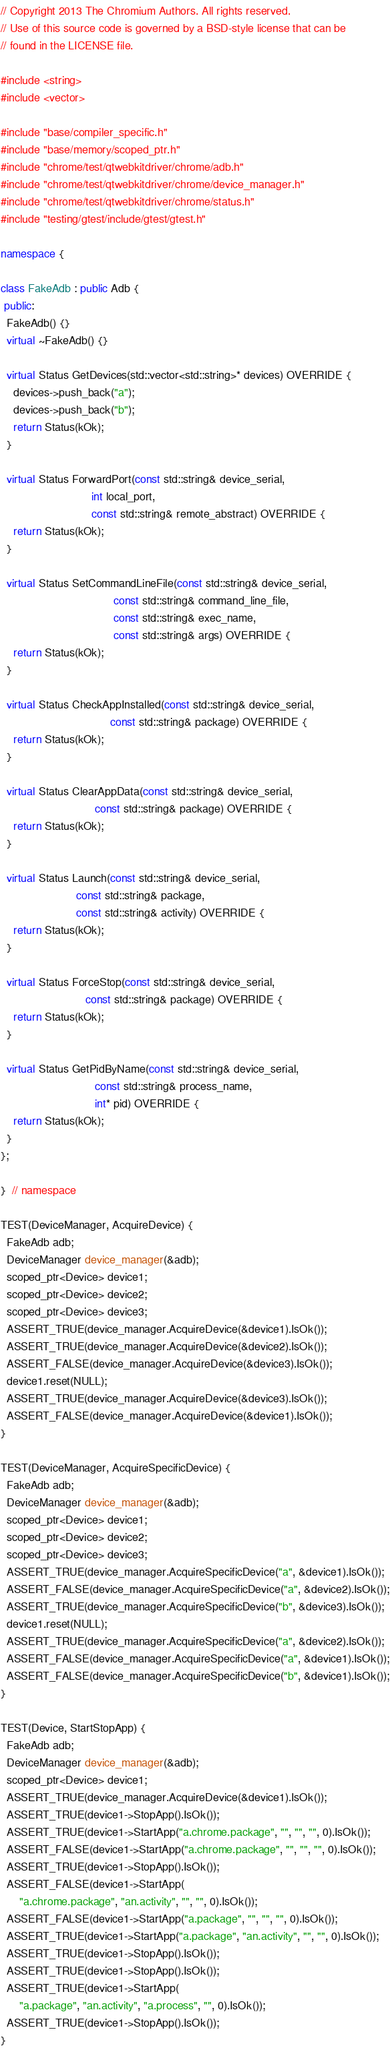<code> <loc_0><loc_0><loc_500><loc_500><_C++_>// Copyright 2013 The Chromium Authors. All rights reserved.
// Use of this source code is governed by a BSD-style license that can be
// found in the LICENSE file.

#include <string>
#include <vector>

#include "base/compiler_specific.h"
#include "base/memory/scoped_ptr.h"
#include "chrome/test/qtwebkitdriver/chrome/adb.h"
#include "chrome/test/qtwebkitdriver/chrome/device_manager.h"
#include "chrome/test/qtwebkitdriver/chrome/status.h"
#include "testing/gtest/include/gtest/gtest.h"

namespace {

class FakeAdb : public Adb {
 public:
  FakeAdb() {}
  virtual ~FakeAdb() {}

  virtual Status GetDevices(std::vector<std::string>* devices) OVERRIDE {
    devices->push_back("a");
    devices->push_back("b");
    return Status(kOk);
  }

  virtual Status ForwardPort(const std::string& device_serial,
                             int local_port,
                             const std::string& remote_abstract) OVERRIDE {
    return Status(kOk);
  }

  virtual Status SetCommandLineFile(const std::string& device_serial,
                                    const std::string& command_line_file,
                                    const std::string& exec_name,
                                    const std::string& args) OVERRIDE {
    return Status(kOk);
  }

  virtual Status CheckAppInstalled(const std::string& device_serial,
                                   const std::string& package) OVERRIDE {
    return Status(kOk);
  }

  virtual Status ClearAppData(const std::string& device_serial,
                              const std::string& package) OVERRIDE {
    return Status(kOk);
  }

  virtual Status Launch(const std::string& device_serial,
                        const std::string& package,
                        const std::string& activity) OVERRIDE {
    return Status(kOk);
  }

  virtual Status ForceStop(const std::string& device_serial,
                           const std::string& package) OVERRIDE {
    return Status(kOk);
  }

  virtual Status GetPidByName(const std::string& device_serial,
                              const std::string& process_name,
                              int* pid) OVERRIDE {
    return Status(kOk);
  }
};

}  // namespace

TEST(DeviceManager, AcquireDevice) {
  FakeAdb adb;
  DeviceManager device_manager(&adb);
  scoped_ptr<Device> device1;
  scoped_ptr<Device> device2;
  scoped_ptr<Device> device3;
  ASSERT_TRUE(device_manager.AcquireDevice(&device1).IsOk());
  ASSERT_TRUE(device_manager.AcquireDevice(&device2).IsOk());
  ASSERT_FALSE(device_manager.AcquireDevice(&device3).IsOk());
  device1.reset(NULL);
  ASSERT_TRUE(device_manager.AcquireDevice(&device3).IsOk());
  ASSERT_FALSE(device_manager.AcquireDevice(&device1).IsOk());
}

TEST(DeviceManager, AcquireSpecificDevice) {
  FakeAdb adb;
  DeviceManager device_manager(&adb);
  scoped_ptr<Device> device1;
  scoped_ptr<Device> device2;
  scoped_ptr<Device> device3;
  ASSERT_TRUE(device_manager.AcquireSpecificDevice("a", &device1).IsOk());
  ASSERT_FALSE(device_manager.AcquireSpecificDevice("a", &device2).IsOk());
  ASSERT_TRUE(device_manager.AcquireSpecificDevice("b", &device3).IsOk());
  device1.reset(NULL);
  ASSERT_TRUE(device_manager.AcquireSpecificDevice("a", &device2).IsOk());
  ASSERT_FALSE(device_manager.AcquireSpecificDevice("a", &device1).IsOk());
  ASSERT_FALSE(device_manager.AcquireSpecificDevice("b", &device1).IsOk());
}

TEST(Device, StartStopApp) {
  FakeAdb adb;
  DeviceManager device_manager(&adb);
  scoped_ptr<Device> device1;
  ASSERT_TRUE(device_manager.AcquireDevice(&device1).IsOk());
  ASSERT_TRUE(device1->StopApp().IsOk());
  ASSERT_TRUE(device1->StartApp("a.chrome.package", "", "", "", 0).IsOk());
  ASSERT_FALSE(device1->StartApp("a.chrome.package", "", "", "", 0).IsOk());
  ASSERT_TRUE(device1->StopApp().IsOk());
  ASSERT_FALSE(device1->StartApp(
      "a.chrome.package", "an.activity", "", "", 0).IsOk());
  ASSERT_FALSE(device1->StartApp("a.package", "", "", "", 0).IsOk());
  ASSERT_TRUE(device1->StartApp("a.package", "an.activity", "", "", 0).IsOk());
  ASSERT_TRUE(device1->StopApp().IsOk());
  ASSERT_TRUE(device1->StopApp().IsOk());
  ASSERT_TRUE(device1->StartApp(
      "a.package", "an.activity", "a.process", "", 0).IsOk());
  ASSERT_TRUE(device1->StopApp().IsOk());
}
</code> 